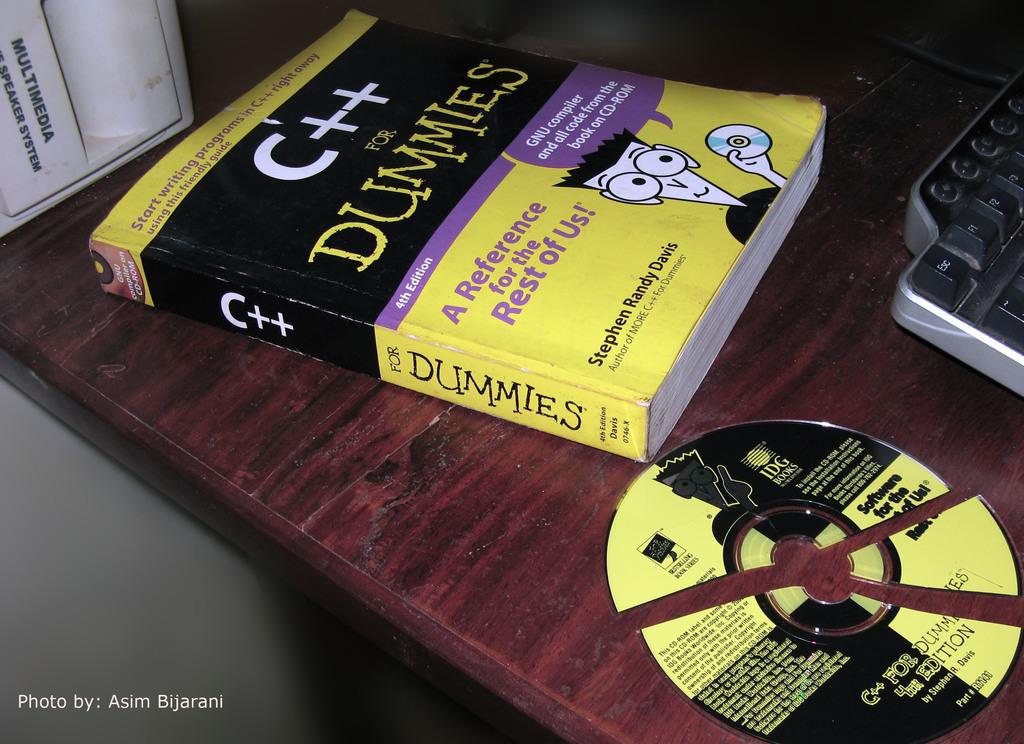Who is the c++ book directed at to help learning?
Give a very brief answer. Dummies. Who is the author of this book?
Ensure brevity in your answer.  Stephen randy davis. 